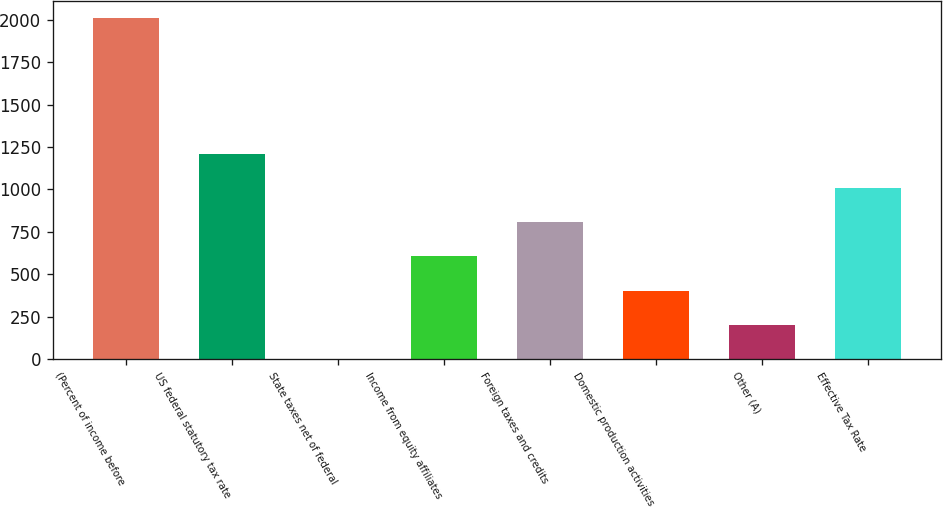Convert chart. <chart><loc_0><loc_0><loc_500><loc_500><bar_chart><fcel>(Percent of income before<fcel>US federal statutory tax rate<fcel>State taxes net of federal<fcel>Income from equity affiliates<fcel>Foreign taxes and credits<fcel>Domestic production activities<fcel>Other (A)<fcel>Effective Tax Rate<nl><fcel>2012<fcel>1207.48<fcel>0.7<fcel>604.09<fcel>805.22<fcel>402.96<fcel>201.83<fcel>1006.35<nl></chart> 